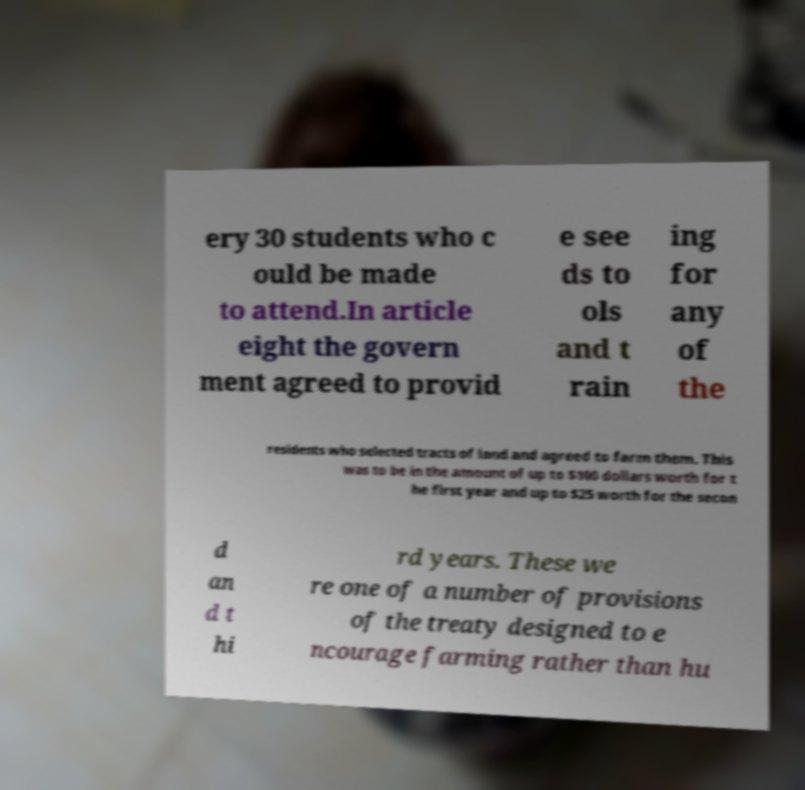What messages or text are displayed in this image? I need them in a readable, typed format. ery 30 students who c ould be made to attend.In article eight the govern ment agreed to provid e see ds to ols and t rain ing for any of the residents who selected tracts of land and agreed to farm them. This was to be in the amount of up to $100 dollars worth for t he first year and up to $25 worth for the secon d an d t hi rd years. These we re one of a number of provisions of the treaty designed to e ncourage farming rather than hu 